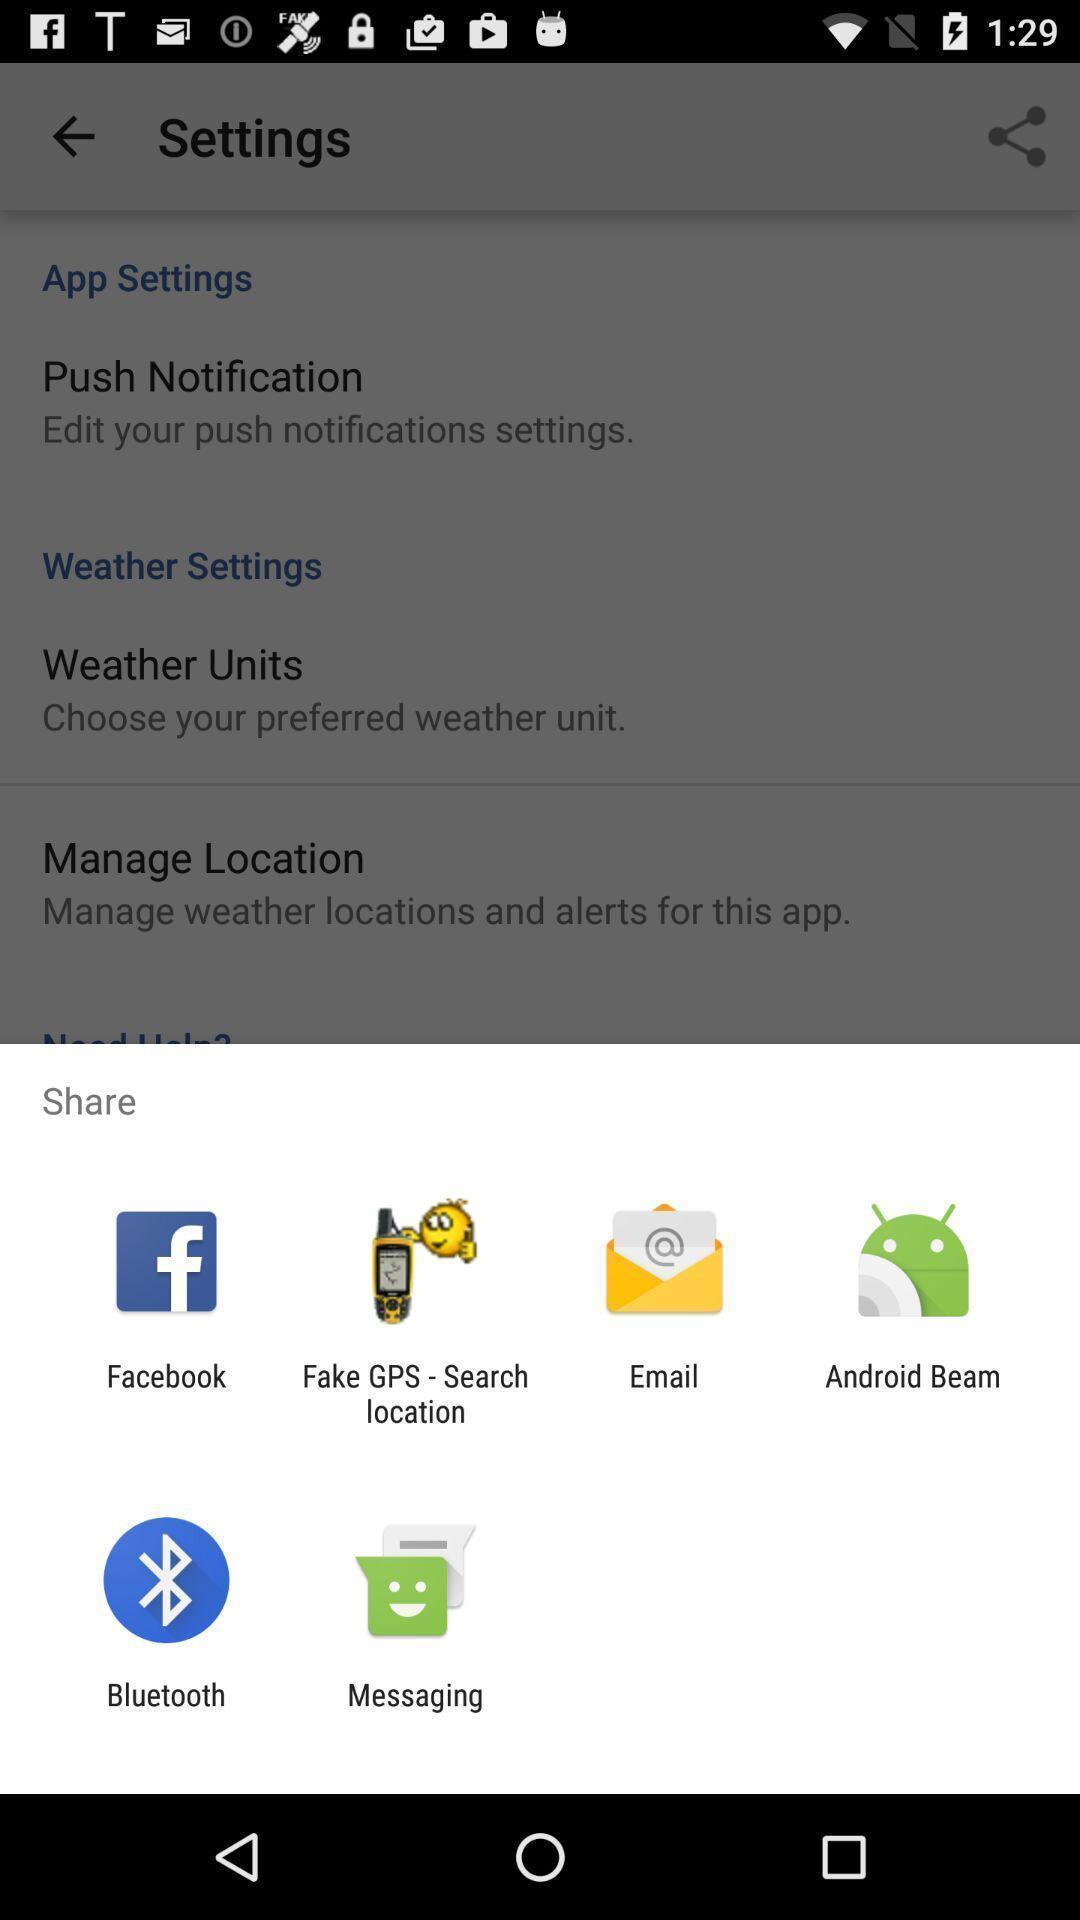Provide a description of this screenshot. Share information with different apps. 